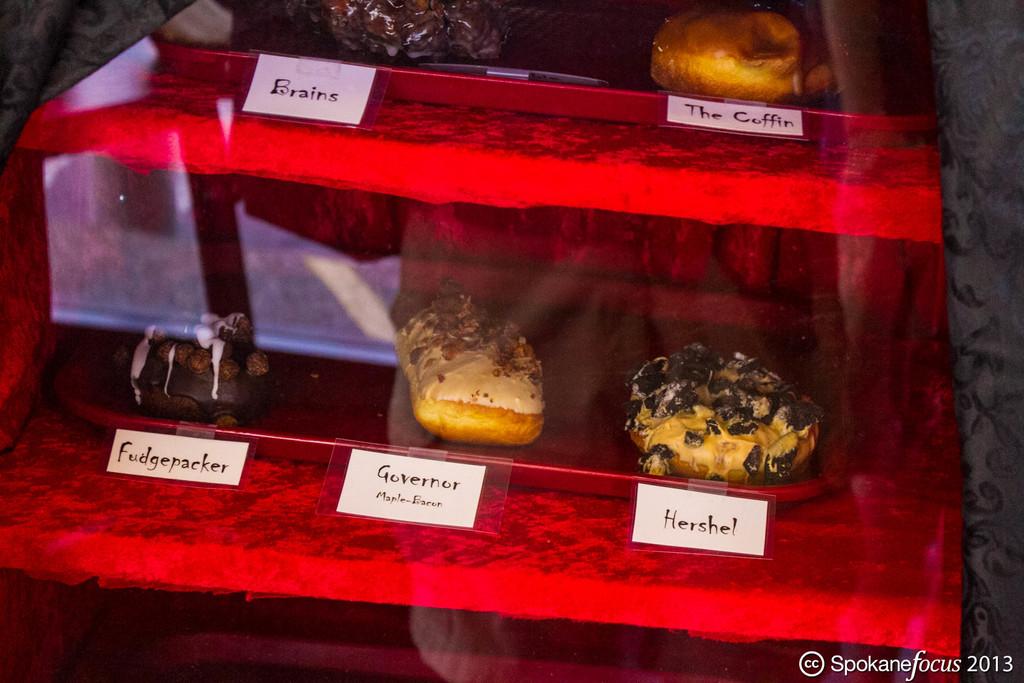What is the bottom right dessert called?
Offer a very short reply. Hershel. 